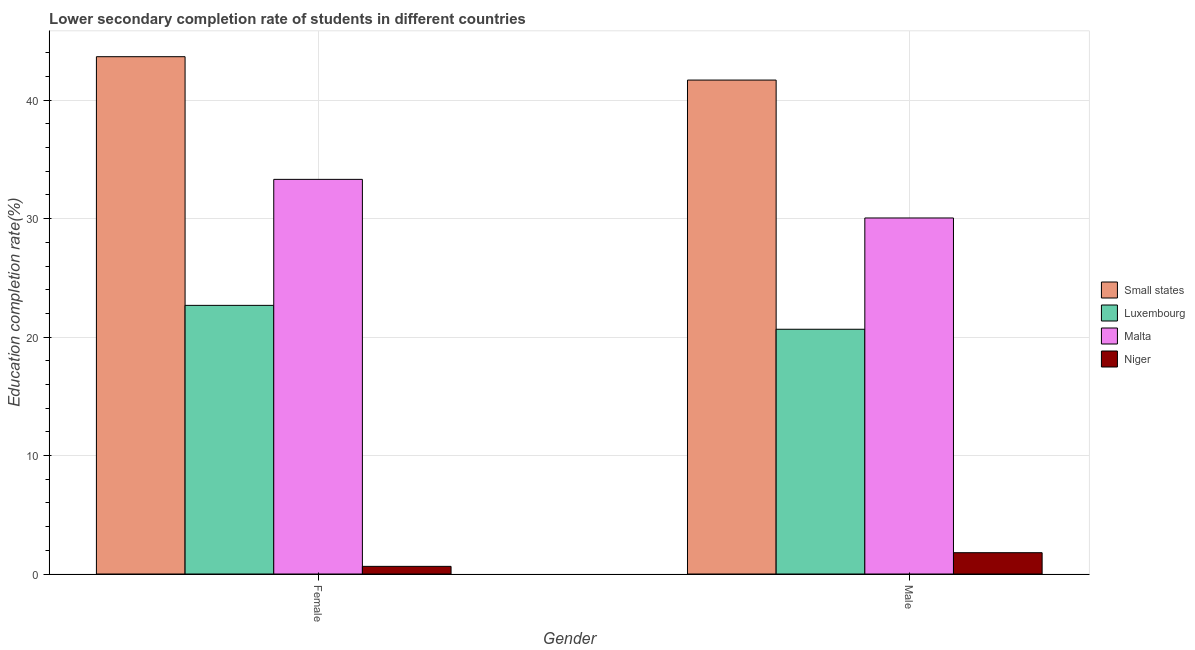How many groups of bars are there?
Your answer should be very brief. 2. Are the number of bars per tick equal to the number of legend labels?
Your response must be concise. Yes. How many bars are there on the 2nd tick from the right?
Offer a terse response. 4. What is the education completion rate of female students in Malta?
Provide a succinct answer. 33.31. Across all countries, what is the maximum education completion rate of male students?
Provide a succinct answer. 41.7. Across all countries, what is the minimum education completion rate of female students?
Your answer should be compact. 0.65. In which country was the education completion rate of female students maximum?
Provide a short and direct response. Small states. In which country was the education completion rate of male students minimum?
Provide a succinct answer. Niger. What is the total education completion rate of male students in the graph?
Offer a very short reply. 94.21. What is the difference between the education completion rate of male students in Small states and that in Niger?
Provide a short and direct response. 39.9. What is the difference between the education completion rate of male students in Niger and the education completion rate of female students in Small states?
Provide a succinct answer. -41.87. What is the average education completion rate of male students per country?
Your answer should be compact. 23.55. What is the difference between the education completion rate of male students and education completion rate of female students in Small states?
Your answer should be very brief. -1.97. In how many countries, is the education completion rate of male students greater than 16 %?
Keep it short and to the point. 3. What is the ratio of the education completion rate of female students in Small states to that in Luxembourg?
Make the answer very short. 1.93. Is the education completion rate of female students in Small states less than that in Luxembourg?
Give a very brief answer. No. In how many countries, is the education completion rate of female students greater than the average education completion rate of female students taken over all countries?
Ensure brevity in your answer.  2. What does the 1st bar from the left in Female represents?
Your response must be concise. Small states. What does the 2nd bar from the right in Male represents?
Provide a succinct answer. Malta. Are all the bars in the graph horizontal?
Provide a succinct answer. No. How many countries are there in the graph?
Ensure brevity in your answer.  4. Where does the legend appear in the graph?
Provide a succinct answer. Center right. How are the legend labels stacked?
Provide a short and direct response. Vertical. What is the title of the graph?
Keep it short and to the point. Lower secondary completion rate of students in different countries. What is the label or title of the X-axis?
Your answer should be very brief. Gender. What is the label or title of the Y-axis?
Make the answer very short. Education completion rate(%). What is the Education completion rate(%) in Small states in Female?
Keep it short and to the point. 43.67. What is the Education completion rate(%) in Luxembourg in Female?
Offer a very short reply. 22.68. What is the Education completion rate(%) in Malta in Female?
Your response must be concise. 33.31. What is the Education completion rate(%) in Niger in Female?
Provide a short and direct response. 0.65. What is the Education completion rate(%) of Small states in Male?
Your answer should be compact. 41.7. What is the Education completion rate(%) of Luxembourg in Male?
Your answer should be compact. 20.66. What is the Education completion rate(%) of Malta in Male?
Offer a very short reply. 30.05. What is the Education completion rate(%) in Niger in Male?
Your response must be concise. 1.8. Across all Gender, what is the maximum Education completion rate(%) in Small states?
Give a very brief answer. 43.67. Across all Gender, what is the maximum Education completion rate(%) of Luxembourg?
Offer a terse response. 22.68. Across all Gender, what is the maximum Education completion rate(%) in Malta?
Provide a short and direct response. 33.31. Across all Gender, what is the maximum Education completion rate(%) in Niger?
Offer a very short reply. 1.8. Across all Gender, what is the minimum Education completion rate(%) of Small states?
Ensure brevity in your answer.  41.7. Across all Gender, what is the minimum Education completion rate(%) in Luxembourg?
Make the answer very short. 20.66. Across all Gender, what is the minimum Education completion rate(%) of Malta?
Keep it short and to the point. 30.05. Across all Gender, what is the minimum Education completion rate(%) of Niger?
Give a very brief answer. 0.65. What is the total Education completion rate(%) in Small states in the graph?
Give a very brief answer. 85.37. What is the total Education completion rate(%) in Luxembourg in the graph?
Your response must be concise. 43.34. What is the total Education completion rate(%) in Malta in the graph?
Your answer should be very brief. 63.37. What is the total Education completion rate(%) of Niger in the graph?
Offer a very short reply. 2.44. What is the difference between the Education completion rate(%) in Small states in Female and that in Male?
Make the answer very short. 1.97. What is the difference between the Education completion rate(%) of Luxembourg in Female and that in Male?
Keep it short and to the point. 2.02. What is the difference between the Education completion rate(%) in Malta in Female and that in Male?
Ensure brevity in your answer.  3.26. What is the difference between the Education completion rate(%) in Niger in Female and that in Male?
Your answer should be very brief. -1.15. What is the difference between the Education completion rate(%) of Small states in Female and the Education completion rate(%) of Luxembourg in Male?
Your answer should be compact. 23.01. What is the difference between the Education completion rate(%) of Small states in Female and the Education completion rate(%) of Malta in Male?
Your response must be concise. 13.62. What is the difference between the Education completion rate(%) in Small states in Female and the Education completion rate(%) in Niger in Male?
Offer a very short reply. 41.87. What is the difference between the Education completion rate(%) in Luxembourg in Female and the Education completion rate(%) in Malta in Male?
Provide a short and direct response. -7.38. What is the difference between the Education completion rate(%) in Luxembourg in Female and the Education completion rate(%) in Niger in Male?
Your response must be concise. 20.88. What is the difference between the Education completion rate(%) of Malta in Female and the Education completion rate(%) of Niger in Male?
Provide a succinct answer. 31.52. What is the average Education completion rate(%) of Small states per Gender?
Ensure brevity in your answer.  42.68. What is the average Education completion rate(%) in Luxembourg per Gender?
Your answer should be compact. 21.67. What is the average Education completion rate(%) in Malta per Gender?
Your answer should be compact. 31.68. What is the average Education completion rate(%) in Niger per Gender?
Provide a succinct answer. 1.22. What is the difference between the Education completion rate(%) of Small states and Education completion rate(%) of Luxembourg in Female?
Provide a succinct answer. 20.99. What is the difference between the Education completion rate(%) in Small states and Education completion rate(%) in Malta in Female?
Your answer should be compact. 10.36. What is the difference between the Education completion rate(%) of Small states and Education completion rate(%) of Niger in Female?
Provide a succinct answer. 43.03. What is the difference between the Education completion rate(%) of Luxembourg and Education completion rate(%) of Malta in Female?
Provide a short and direct response. -10.64. What is the difference between the Education completion rate(%) of Luxembourg and Education completion rate(%) of Niger in Female?
Your answer should be very brief. 22.03. What is the difference between the Education completion rate(%) in Malta and Education completion rate(%) in Niger in Female?
Make the answer very short. 32.67. What is the difference between the Education completion rate(%) of Small states and Education completion rate(%) of Luxembourg in Male?
Make the answer very short. 21.04. What is the difference between the Education completion rate(%) in Small states and Education completion rate(%) in Malta in Male?
Provide a succinct answer. 11.64. What is the difference between the Education completion rate(%) in Small states and Education completion rate(%) in Niger in Male?
Give a very brief answer. 39.9. What is the difference between the Education completion rate(%) of Luxembourg and Education completion rate(%) of Malta in Male?
Keep it short and to the point. -9.39. What is the difference between the Education completion rate(%) in Luxembourg and Education completion rate(%) in Niger in Male?
Your answer should be very brief. 18.86. What is the difference between the Education completion rate(%) of Malta and Education completion rate(%) of Niger in Male?
Provide a short and direct response. 28.26. What is the ratio of the Education completion rate(%) in Small states in Female to that in Male?
Make the answer very short. 1.05. What is the ratio of the Education completion rate(%) in Luxembourg in Female to that in Male?
Your response must be concise. 1.1. What is the ratio of the Education completion rate(%) in Malta in Female to that in Male?
Provide a short and direct response. 1.11. What is the ratio of the Education completion rate(%) in Niger in Female to that in Male?
Make the answer very short. 0.36. What is the difference between the highest and the second highest Education completion rate(%) in Small states?
Your response must be concise. 1.97. What is the difference between the highest and the second highest Education completion rate(%) of Luxembourg?
Keep it short and to the point. 2.02. What is the difference between the highest and the second highest Education completion rate(%) in Malta?
Your response must be concise. 3.26. What is the difference between the highest and the second highest Education completion rate(%) of Niger?
Your response must be concise. 1.15. What is the difference between the highest and the lowest Education completion rate(%) in Small states?
Provide a succinct answer. 1.97. What is the difference between the highest and the lowest Education completion rate(%) of Luxembourg?
Provide a short and direct response. 2.02. What is the difference between the highest and the lowest Education completion rate(%) in Malta?
Keep it short and to the point. 3.26. What is the difference between the highest and the lowest Education completion rate(%) of Niger?
Your answer should be compact. 1.15. 